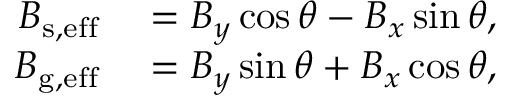<formula> <loc_0><loc_0><loc_500><loc_500>\begin{array} { r l } { B _ { s , e f f } } & = B _ { y } \cos \theta - B _ { x } \sin \theta , } \\ { B _ { g , e f f } } & = B _ { y } \sin \theta + B _ { x } \cos \theta , } \end{array}</formula> 